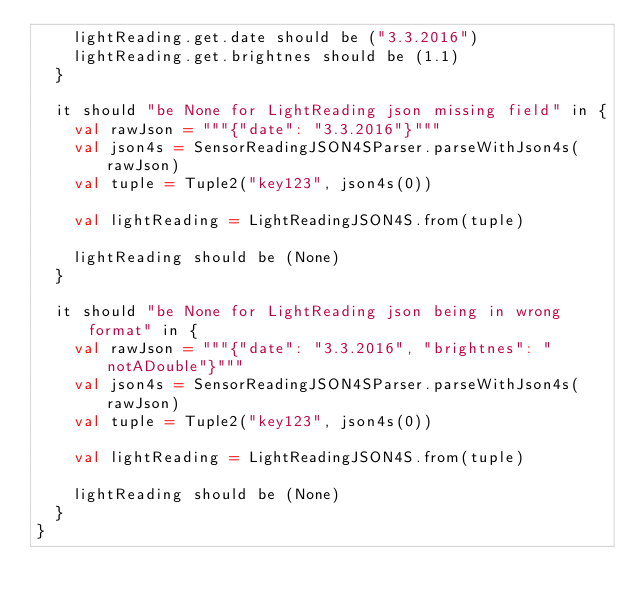Convert code to text. <code><loc_0><loc_0><loc_500><loc_500><_Scala_>    lightReading.get.date should be ("3.3.2016")
    lightReading.get.brightnes should be (1.1)
  }

  it should "be None for LightReading json missing field" in {
    val rawJson = """{"date": "3.3.2016"}"""
    val json4s = SensorReadingJSON4SParser.parseWithJson4s(rawJson)
    val tuple = Tuple2("key123", json4s(0))

    val lightReading = LightReadingJSON4S.from(tuple)

    lightReading should be (None)
  }

  it should "be None for LightReading json being in wrong format" in {
    val rawJson = """{"date": "3.3.2016", "brightnes": "notADouble"}"""
    val json4s = SensorReadingJSON4SParser.parseWithJson4s(rawJson)
    val tuple = Tuple2("key123", json4s(0))

    val lightReading = LightReadingJSON4S.from(tuple)

    lightReading should be (None)
  }
}</code> 